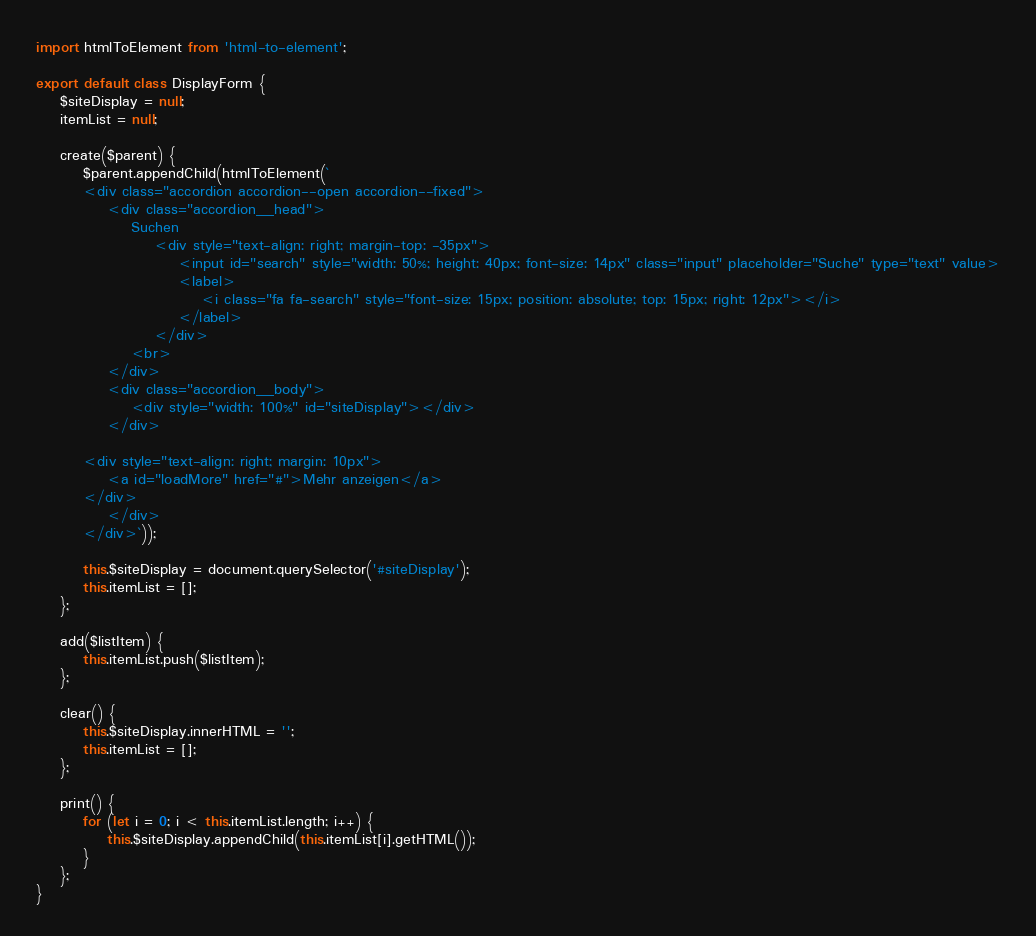Convert code to text. <code><loc_0><loc_0><loc_500><loc_500><_JavaScript_>import htmlToElement from 'html-to-element';

export default class DisplayForm {
    $siteDisplay = null;
    itemList = null;

    create($parent) {
        $parent.appendChild(htmlToElement(`
        <div class="accordion accordion--open accordion--fixed">
            <div class="accordion__head">
                Suchen 
                    <div style="text-align: right; margin-top: -35px">
                        <input id="search" style="width: 50%; height: 40px; font-size: 14px" class="input" placeholder="Suche" type="text" value>
                        <label>
                            <i class="fa fa-search" style="font-size: 15px; position: absolute; top: 15px; right: 12px"></i>
                        </label>
                    </div>
                <br>
            </div>
            <div class="accordion__body">
                <div style="width: 100%" id="siteDisplay"></div>
            </div>

        <div style="text-align: right; margin: 10px">
            <a id="loadMore" href="#">Mehr anzeigen</a>
        </div>
            </div>
        </div>`));

        this.$siteDisplay = document.querySelector('#siteDisplay');
        this.itemList = [];
    };

    add($listItem) {
        this.itemList.push($listItem);
    };

    clear() {
        this.$siteDisplay.innerHTML = '';
        this.itemList = [];
    };

    print() {
        for (let i = 0; i < this.itemList.length; i++) {
            this.$siteDisplay.appendChild(this.itemList[i].getHTML());
        }
    };
}</code> 